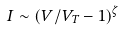Convert formula to latex. <formula><loc_0><loc_0><loc_500><loc_500>I \sim ( V / V _ { T } - 1 ) ^ { \zeta }</formula> 